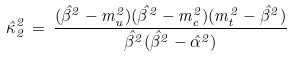<formula> <loc_0><loc_0><loc_500><loc_500>\hat { \kappa } _ { 2 } ^ { 2 } \, = \, \frac { ( \hat { \beta } ^ { 2 } - m _ { u } ^ { 2 } ) ( \hat { \beta } ^ { 2 } - m _ { c } ^ { 2 } ) ( m _ { t } ^ { 2 } - \hat { \beta } ^ { 2 } ) } { \hat { \beta } ^ { 2 } ( \hat { \beta } ^ { 2 } - \hat { \alpha } ^ { 2 } ) }</formula> 